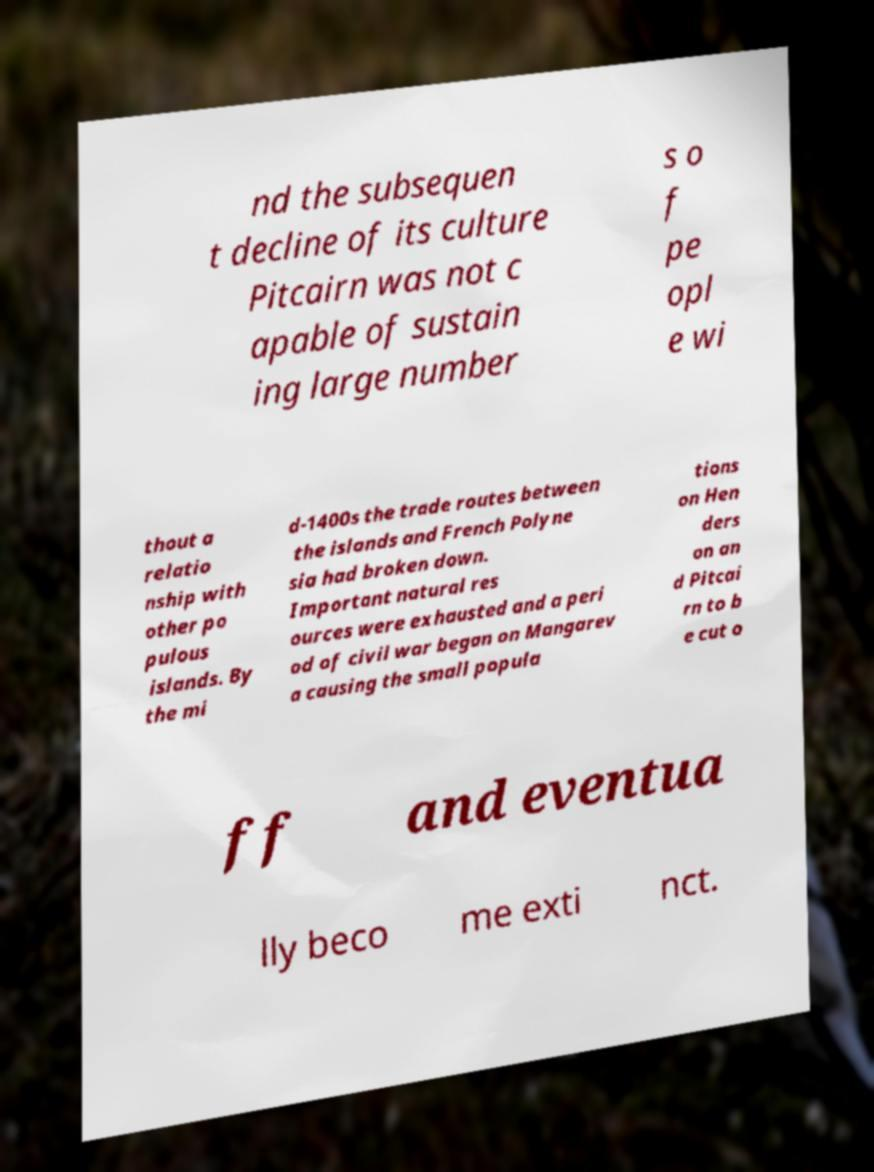Please read and relay the text visible in this image. What does it say? nd the subsequen t decline of its culture Pitcairn was not c apable of sustain ing large number s o f pe opl e wi thout a relatio nship with other po pulous islands. By the mi d-1400s the trade routes between the islands and French Polyne sia had broken down. Important natural res ources were exhausted and a peri od of civil war began on Mangarev a causing the small popula tions on Hen ders on an d Pitcai rn to b e cut o ff and eventua lly beco me exti nct. 